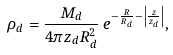Convert formula to latex. <formula><loc_0><loc_0><loc_500><loc_500>\rho _ { d } = \frac { M _ { d } } { 4 \pi z _ { d } R _ { d } ^ { 2 } } \, e ^ { - \frac { R } { R _ { d } } - \left | \frac { z } { z _ { d } } \right | } ,</formula> 